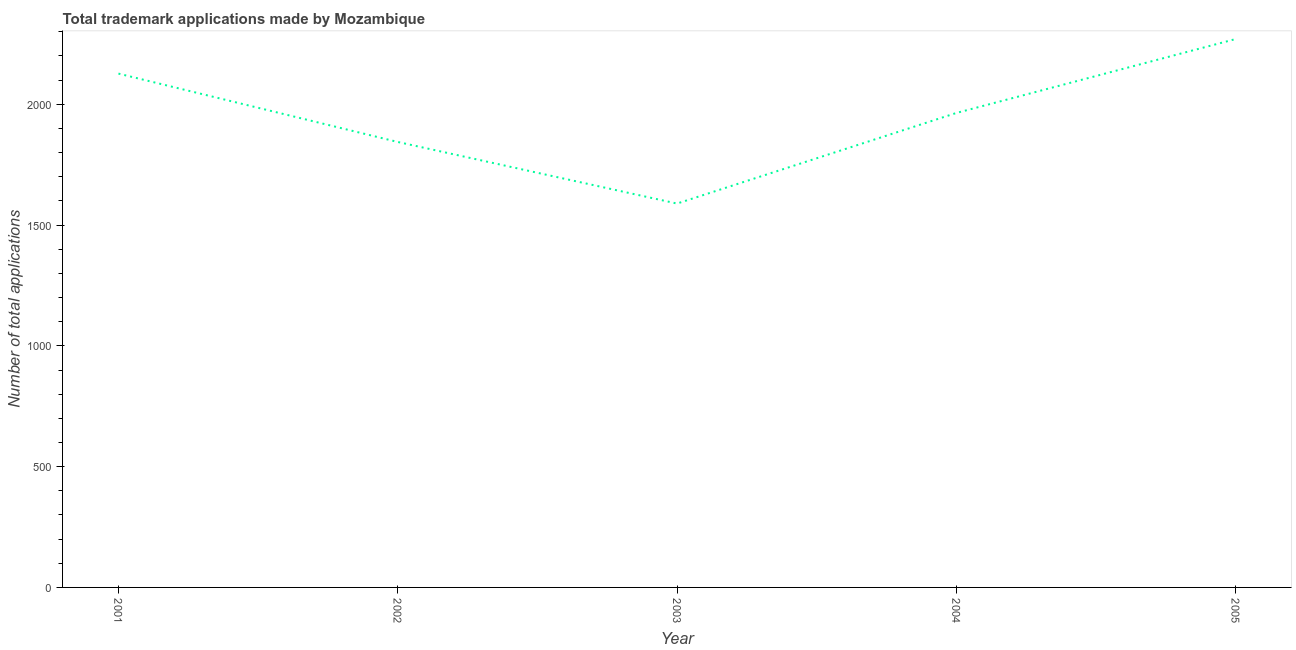What is the number of trademark applications in 2005?
Ensure brevity in your answer.  2270. Across all years, what is the maximum number of trademark applications?
Provide a short and direct response. 2270. Across all years, what is the minimum number of trademark applications?
Keep it short and to the point. 1589. In which year was the number of trademark applications maximum?
Offer a terse response. 2005. In which year was the number of trademark applications minimum?
Provide a succinct answer. 2003. What is the sum of the number of trademark applications?
Give a very brief answer. 9794. What is the difference between the number of trademark applications in 2001 and 2003?
Offer a very short reply. 538. What is the average number of trademark applications per year?
Provide a succinct answer. 1958.8. What is the median number of trademark applications?
Provide a short and direct response. 1964. In how many years, is the number of trademark applications greater than 1200 ?
Make the answer very short. 5. What is the ratio of the number of trademark applications in 2001 to that in 2005?
Provide a short and direct response. 0.94. Is the number of trademark applications in 2004 less than that in 2005?
Offer a very short reply. Yes. Is the difference between the number of trademark applications in 2003 and 2005 greater than the difference between any two years?
Keep it short and to the point. Yes. What is the difference between the highest and the second highest number of trademark applications?
Make the answer very short. 143. Is the sum of the number of trademark applications in 2003 and 2004 greater than the maximum number of trademark applications across all years?
Provide a short and direct response. Yes. What is the difference between the highest and the lowest number of trademark applications?
Provide a short and direct response. 681. In how many years, is the number of trademark applications greater than the average number of trademark applications taken over all years?
Provide a succinct answer. 3. Does the graph contain any zero values?
Your answer should be very brief. No. Does the graph contain grids?
Provide a succinct answer. No. What is the title of the graph?
Provide a succinct answer. Total trademark applications made by Mozambique. What is the label or title of the Y-axis?
Offer a very short reply. Number of total applications. What is the Number of total applications in 2001?
Your answer should be very brief. 2127. What is the Number of total applications of 2002?
Provide a short and direct response. 1844. What is the Number of total applications in 2003?
Give a very brief answer. 1589. What is the Number of total applications of 2004?
Provide a succinct answer. 1964. What is the Number of total applications in 2005?
Your response must be concise. 2270. What is the difference between the Number of total applications in 2001 and 2002?
Your response must be concise. 283. What is the difference between the Number of total applications in 2001 and 2003?
Make the answer very short. 538. What is the difference between the Number of total applications in 2001 and 2004?
Provide a short and direct response. 163. What is the difference between the Number of total applications in 2001 and 2005?
Give a very brief answer. -143. What is the difference between the Number of total applications in 2002 and 2003?
Provide a short and direct response. 255. What is the difference between the Number of total applications in 2002 and 2004?
Offer a terse response. -120. What is the difference between the Number of total applications in 2002 and 2005?
Ensure brevity in your answer.  -426. What is the difference between the Number of total applications in 2003 and 2004?
Offer a very short reply. -375. What is the difference between the Number of total applications in 2003 and 2005?
Your response must be concise. -681. What is the difference between the Number of total applications in 2004 and 2005?
Keep it short and to the point. -306. What is the ratio of the Number of total applications in 2001 to that in 2002?
Provide a succinct answer. 1.15. What is the ratio of the Number of total applications in 2001 to that in 2003?
Ensure brevity in your answer.  1.34. What is the ratio of the Number of total applications in 2001 to that in 2004?
Ensure brevity in your answer.  1.08. What is the ratio of the Number of total applications in 2001 to that in 2005?
Keep it short and to the point. 0.94. What is the ratio of the Number of total applications in 2002 to that in 2003?
Your response must be concise. 1.16. What is the ratio of the Number of total applications in 2002 to that in 2004?
Provide a succinct answer. 0.94. What is the ratio of the Number of total applications in 2002 to that in 2005?
Give a very brief answer. 0.81. What is the ratio of the Number of total applications in 2003 to that in 2004?
Make the answer very short. 0.81. What is the ratio of the Number of total applications in 2004 to that in 2005?
Ensure brevity in your answer.  0.86. 